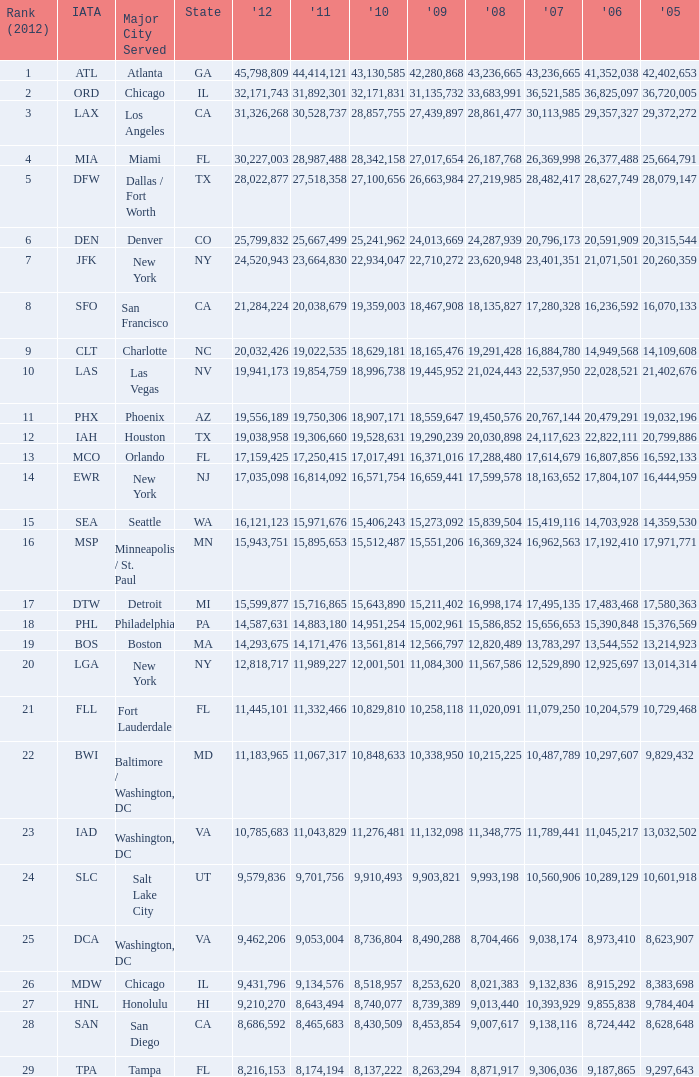For the IATA code of lax with 2009 less than 31,135,732 and 2011 less than 8,174,194, what is the sum of 2012? 0.0. 